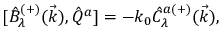Convert formula to latex. <formula><loc_0><loc_0><loc_500><loc_500>{ [ } \hat { B } _ { \lambda } ^ { ( + ) } ( \vec { k } ) , \hat { Q } ^ { a } ] = - k _ { 0 } \hat { C } _ { \lambda } ^ { a ( + ) } ( \vec { k } ) ,</formula> 